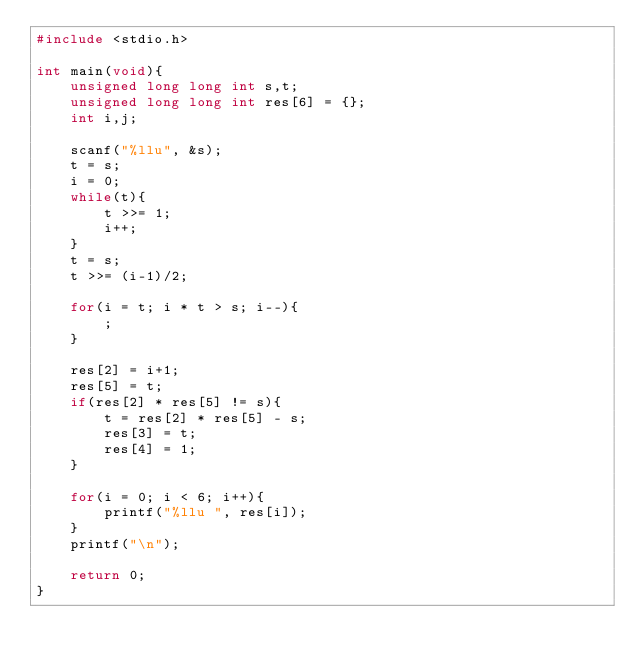Convert code to text. <code><loc_0><loc_0><loc_500><loc_500><_C_>#include <stdio.h>

int main(void){
    unsigned long long int s,t;
    unsigned long long int res[6] = {};
    int i,j;
    
    scanf("%llu", &s);
    t = s;
    i = 0;
    while(t){
        t >>= 1;
        i++;
    }
    t = s;
    t >>= (i-1)/2;
    
    for(i = t; i * t > s; i--){
        ;
    }
    
    res[2] = i+1;
    res[5] = t;
    if(res[2] * res[5] != s){
        t = res[2] * res[5] - s;
        res[3] = t;
        res[4] = 1;
    }
    
    for(i = 0; i < 6; i++){
        printf("%llu ", res[i]);
    }
    printf("\n");
    
    return 0;
}</code> 